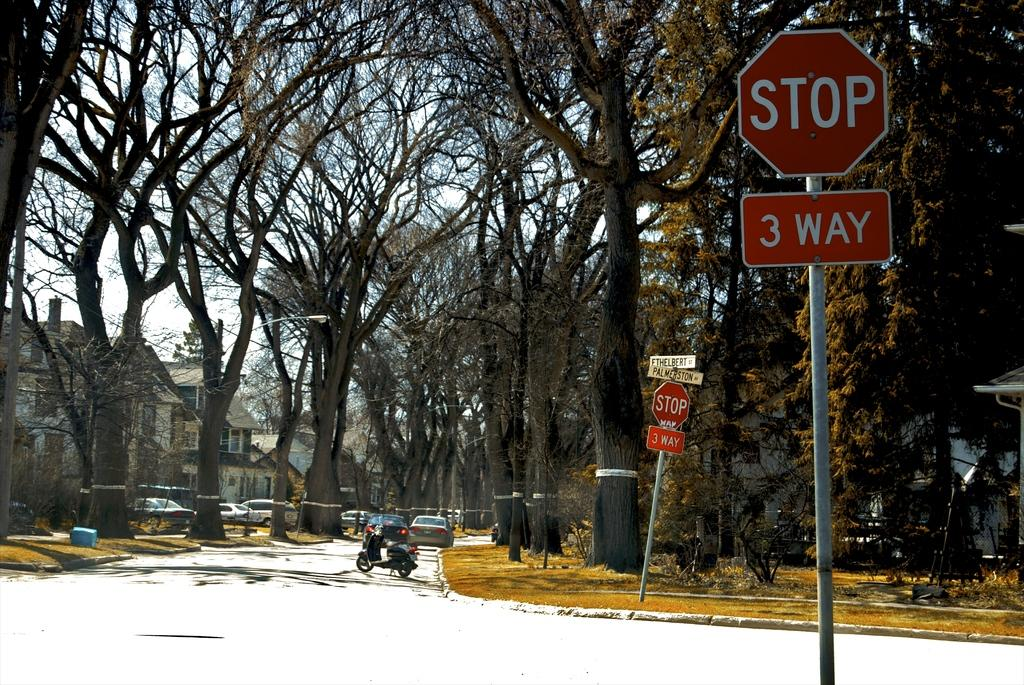<image>
Describe the image concisely. Vehicles on a residential street with a three way stop. 